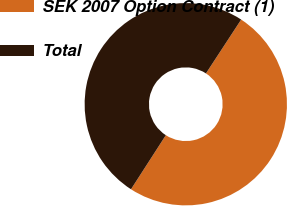Convert chart to OTSL. <chart><loc_0><loc_0><loc_500><loc_500><pie_chart><fcel>SEK 2007 Option Contract (1)<fcel>Total<nl><fcel>49.89%<fcel>50.11%<nl></chart> 